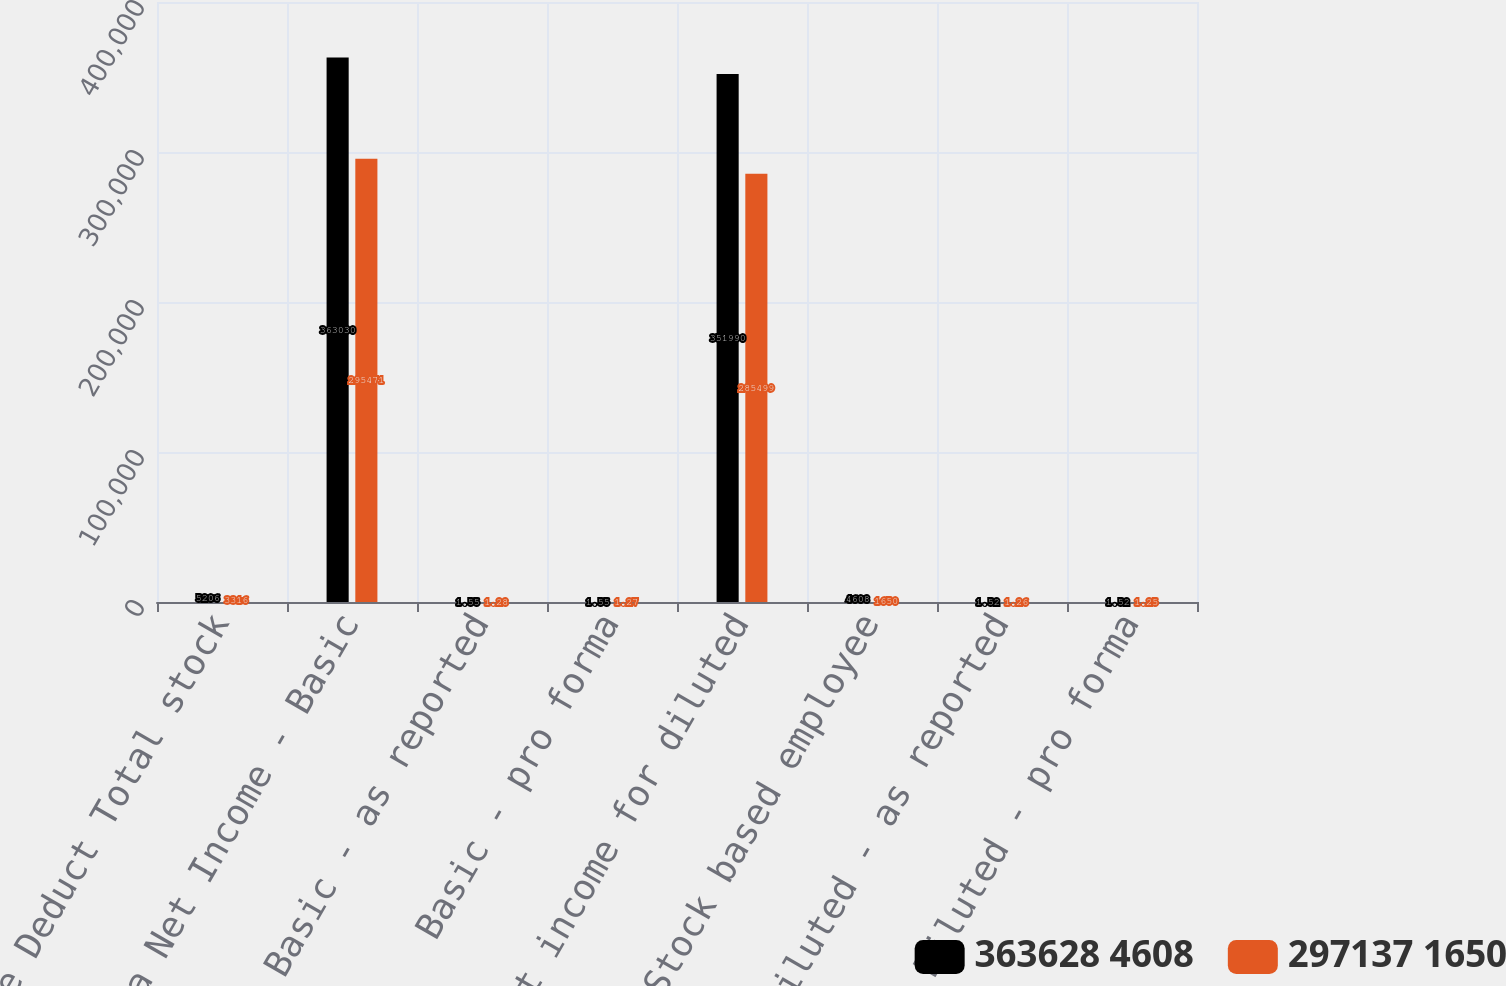Convert chart. <chart><loc_0><loc_0><loc_500><loc_500><stacked_bar_chart><ecel><fcel>income Deduct Total stock<fcel>Pro Forma Net Income - Basic<fcel>Basic - as reported<fcel>Basic - pro forma<fcel>Net income for diluted<fcel>Add Stock based employee<fcel>Diluted - as reported<fcel>Diluted - pro forma<nl><fcel>363628 4608<fcel>5206<fcel>363030<fcel>1.55<fcel>1.55<fcel>351990<fcel>4608<fcel>1.52<fcel>1.52<nl><fcel>297137 1650<fcel>3316<fcel>295471<fcel>1.28<fcel>1.27<fcel>285499<fcel>1650<fcel>1.26<fcel>1.25<nl></chart> 